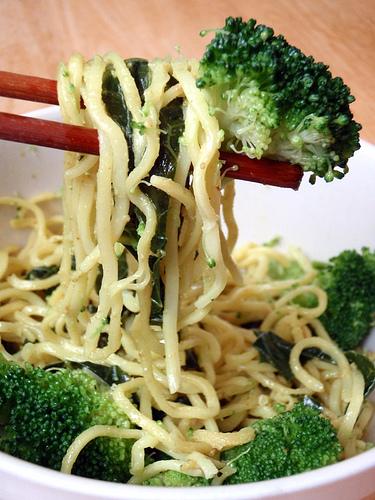What flavor is the food?
Concise answer only. Bland. What is in a bowl?
Keep it brief. Pasta and broccoli. Is this Asian food?
Answer briefly. Yes. Does this meal appear to be bland or well spiced?
Answer briefly. Bland. 